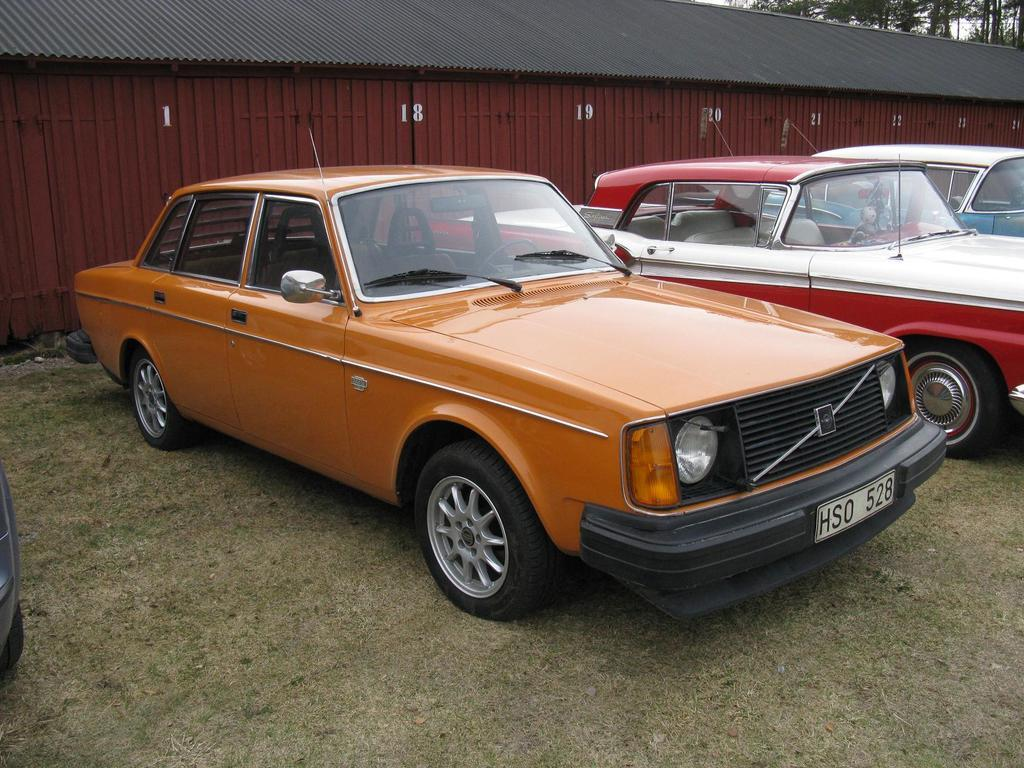What type of vehicles can be seen in the image? There are cars in the image. What distinguishes the cars from one another? The cars are in different colors. What can be seen in the background of the image? There are trees, at least one building, a wall, a roof, and grass in the background of the image. What is written on the wall in the image? There are numbers on the wall. What letter can be seen on the hood of the car in the image? There is no letter visible on the hood of any car in the image. 